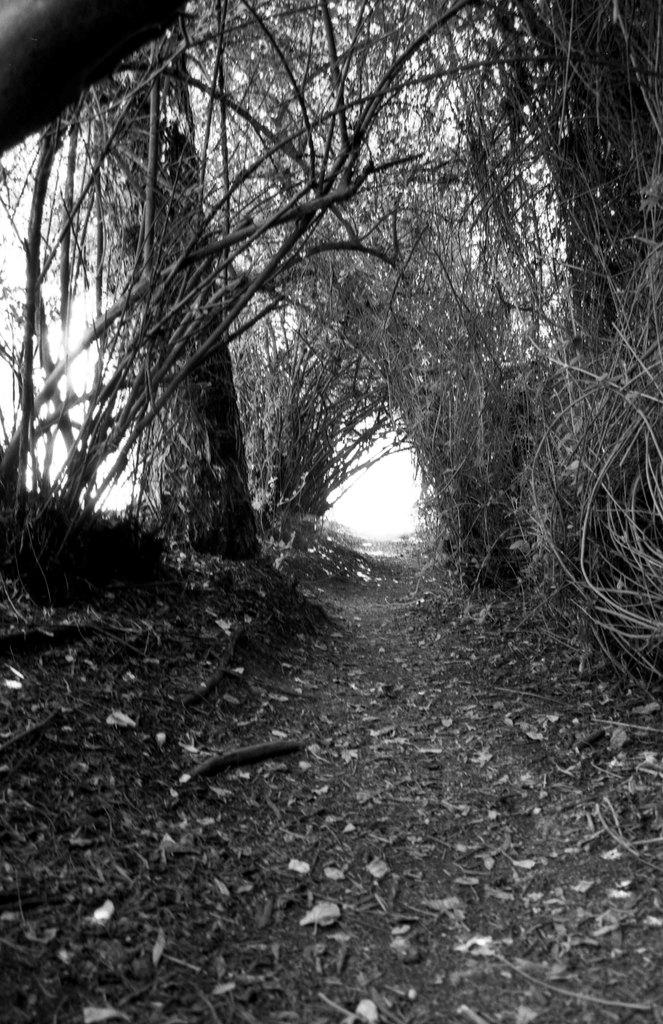What can be seen at the top of the image? The sky is visible in the middle of the image. What is located at the bottom of the image? The ground is present at the bottom of the image. Where is the tree situated in the image? There is a tree on the left side of the image. What color is the debt in the image? There is no debt present in the image, so it is not possible to determine its color. 